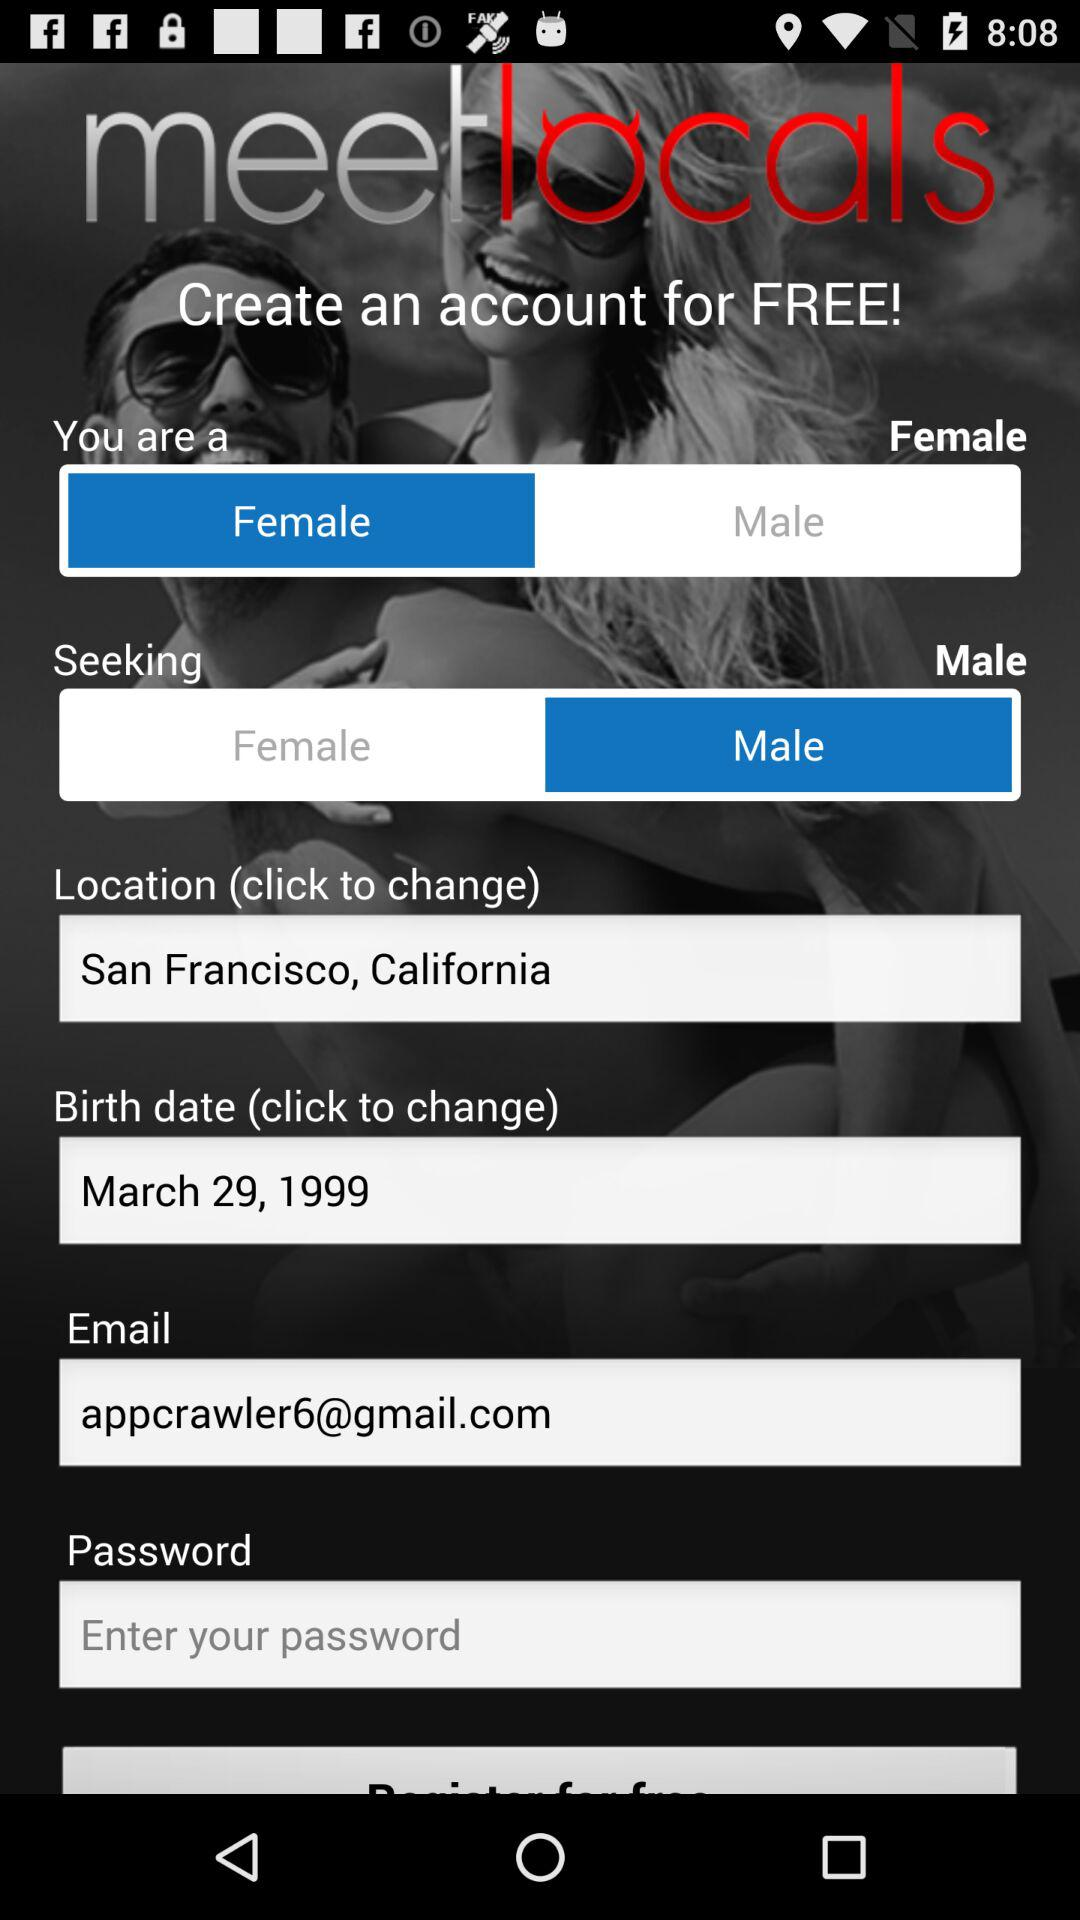What is the date of birth? The date of birth is March 29, 1999. 